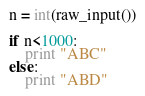Convert code to text. <code><loc_0><loc_0><loc_500><loc_500><_Python_>n = int(raw_input())

if n<1000:
    print "ABC"
else:
    print "ABD"</code> 